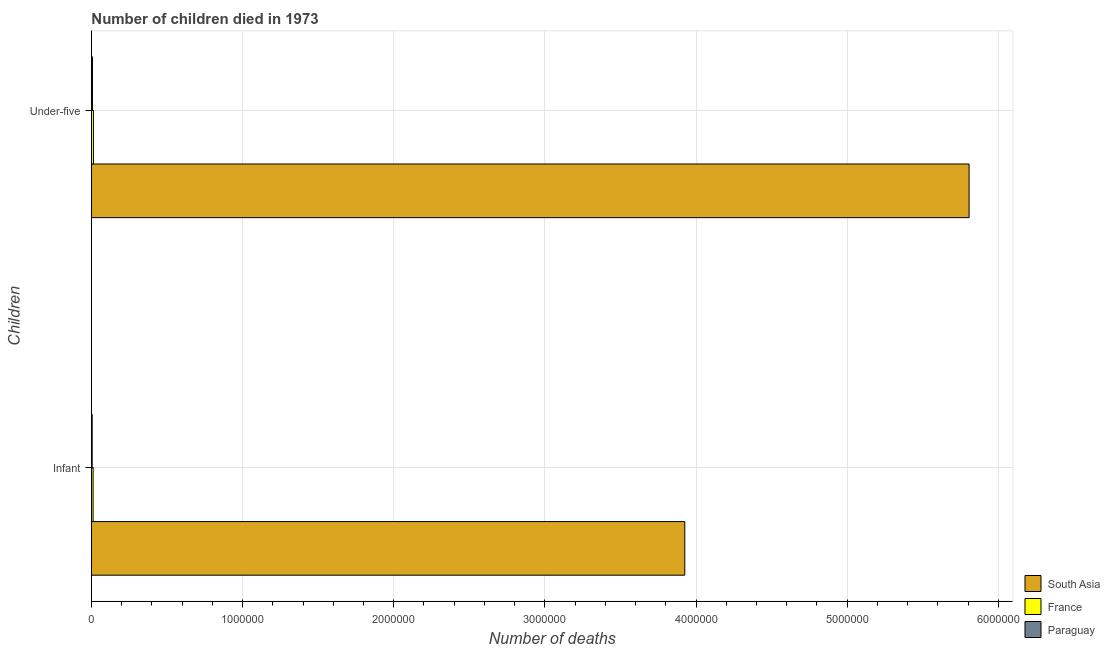How many different coloured bars are there?
Offer a very short reply. 3. Are the number of bars per tick equal to the number of legend labels?
Offer a terse response. Yes. Are the number of bars on each tick of the Y-axis equal?
Your answer should be very brief. Yes. How many bars are there on the 1st tick from the top?
Your answer should be compact. 3. How many bars are there on the 2nd tick from the bottom?
Make the answer very short. 3. What is the label of the 1st group of bars from the top?
Ensure brevity in your answer.  Under-five. What is the number of under-five deaths in France?
Offer a very short reply. 1.34e+04. Across all countries, what is the maximum number of under-five deaths?
Your answer should be compact. 5.81e+06. Across all countries, what is the minimum number of infant deaths?
Offer a very short reply. 5077. In which country was the number of under-five deaths minimum?
Offer a very short reply. Paraguay. What is the total number of infant deaths in the graph?
Provide a succinct answer. 3.94e+06. What is the difference between the number of under-five deaths in France and that in Paraguay?
Give a very brief answer. 6526. What is the difference between the number of under-five deaths in South Asia and the number of infant deaths in Paraguay?
Your answer should be compact. 5.80e+06. What is the average number of infant deaths per country?
Give a very brief answer. 1.31e+06. What is the difference between the number of under-five deaths and number of infant deaths in Paraguay?
Give a very brief answer. 1768. In how many countries, is the number of infant deaths greater than 3200000 ?
Offer a very short reply. 1. What is the ratio of the number of infant deaths in France to that in South Asia?
Offer a very short reply. 0. What does the 1st bar from the top in Infant represents?
Ensure brevity in your answer.  Paraguay. How many bars are there?
Ensure brevity in your answer.  6. What is the difference between two consecutive major ticks on the X-axis?
Provide a succinct answer. 1.00e+06. Does the graph contain any zero values?
Offer a terse response. No. Does the graph contain grids?
Keep it short and to the point. Yes. Where does the legend appear in the graph?
Your answer should be very brief. Bottom right. What is the title of the graph?
Your answer should be compact. Number of children died in 1973. What is the label or title of the X-axis?
Your response must be concise. Number of deaths. What is the label or title of the Y-axis?
Provide a succinct answer. Children. What is the Number of deaths in South Asia in Infant?
Your answer should be very brief. 3.93e+06. What is the Number of deaths of France in Infant?
Make the answer very short. 1.10e+04. What is the Number of deaths of Paraguay in Infant?
Ensure brevity in your answer.  5077. What is the Number of deaths in South Asia in Under-five?
Your answer should be very brief. 5.81e+06. What is the Number of deaths in France in Under-five?
Provide a short and direct response. 1.34e+04. What is the Number of deaths in Paraguay in Under-five?
Provide a short and direct response. 6845. Across all Children, what is the maximum Number of deaths of South Asia?
Your answer should be compact. 5.81e+06. Across all Children, what is the maximum Number of deaths in France?
Offer a very short reply. 1.34e+04. Across all Children, what is the maximum Number of deaths of Paraguay?
Provide a short and direct response. 6845. Across all Children, what is the minimum Number of deaths in South Asia?
Offer a very short reply. 3.93e+06. Across all Children, what is the minimum Number of deaths of France?
Provide a succinct answer. 1.10e+04. Across all Children, what is the minimum Number of deaths in Paraguay?
Your answer should be very brief. 5077. What is the total Number of deaths in South Asia in the graph?
Keep it short and to the point. 9.73e+06. What is the total Number of deaths of France in the graph?
Offer a very short reply. 2.44e+04. What is the total Number of deaths in Paraguay in the graph?
Your response must be concise. 1.19e+04. What is the difference between the Number of deaths in South Asia in Infant and that in Under-five?
Your answer should be very brief. -1.88e+06. What is the difference between the Number of deaths in France in Infant and that in Under-five?
Your answer should be compact. -2356. What is the difference between the Number of deaths of Paraguay in Infant and that in Under-five?
Provide a short and direct response. -1768. What is the difference between the Number of deaths in South Asia in Infant and the Number of deaths in France in Under-five?
Your response must be concise. 3.91e+06. What is the difference between the Number of deaths in South Asia in Infant and the Number of deaths in Paraguay in Under-five?
Ensure brevity in your answer.  3.92e+06. What is the difference between the Number of deaths in France in Infant and the Number of deaths in Paraguay in Under-five?
Your answer should be compact. 4170. What is the average Number of deaths in South Asia per Children?
Your answer should be very brief. 4.87e+06. What is the average Number of deaths of France per Children?
Make the answer very short. 1.22e+04. What is the average Number of deaths in Paraguay per Children?
Your answer should be compact. 5961. What is the difference between the Number of deaths of South Asia and Number of deaths of France in Infant?
Offer a terse response. 3.91e+06. What is the difference between the Number of deaths of South Asia and Number of deaths of Paraguay in Infant?
Ensure brevity in your answer.  3.92e+06. What is the difference between the Number of deaths in France and Number of deaths in Paraguay in Infant?
Make the answer very short. 5938. What is the difference between the Number of deaths in South Asia and Number of deaths in France in Under-five?
Offer a very short reply. 5.79e+06. What is the difference between the Number of deaths in South Asia and Number of deaths in Paraguay in Under-five?
Offer a very short reply. 5.80e+06. What is the difference between the Number of deaths in France and Number of deaths in Paraguay in Under-five?
Provide a succinct answer. 6526. What is the ratio of the Number of deaths of South Asia in Infant to that in Under-five?
Provide a succinct answer. 0.68. What is the ratio of the Number of deaths in France in Infant to that in Under-five?
Your response must be concise. 0.82. What is the ratio of the Number of deaths in Paraguay in Infant to that in Under-five?
Offer a terse response. 0.74. What is the difference between the highest and the second highest Number of deaths of South Asia?
Keep it short and to the point. 1.88e+06. What is the difference between the highest and the second highest Number of deaths of France?
Make the answer very short. 2356. What is the difference between the highest and the second highest Number of deaths of Paraguay?
Provide a succinct answer. 1768. What is the difference between the highest and the lowest Number of deaths of South Asia?
Provide a short and direct response. 1.88e+06. What is the difference between the highest and the lowest Number of deaths in France?
Your answer should be very brief. 2356. What is the difference between the highest and the lowest Number of deaths in Paraguay?
Provide a succinct answer. 1768. 